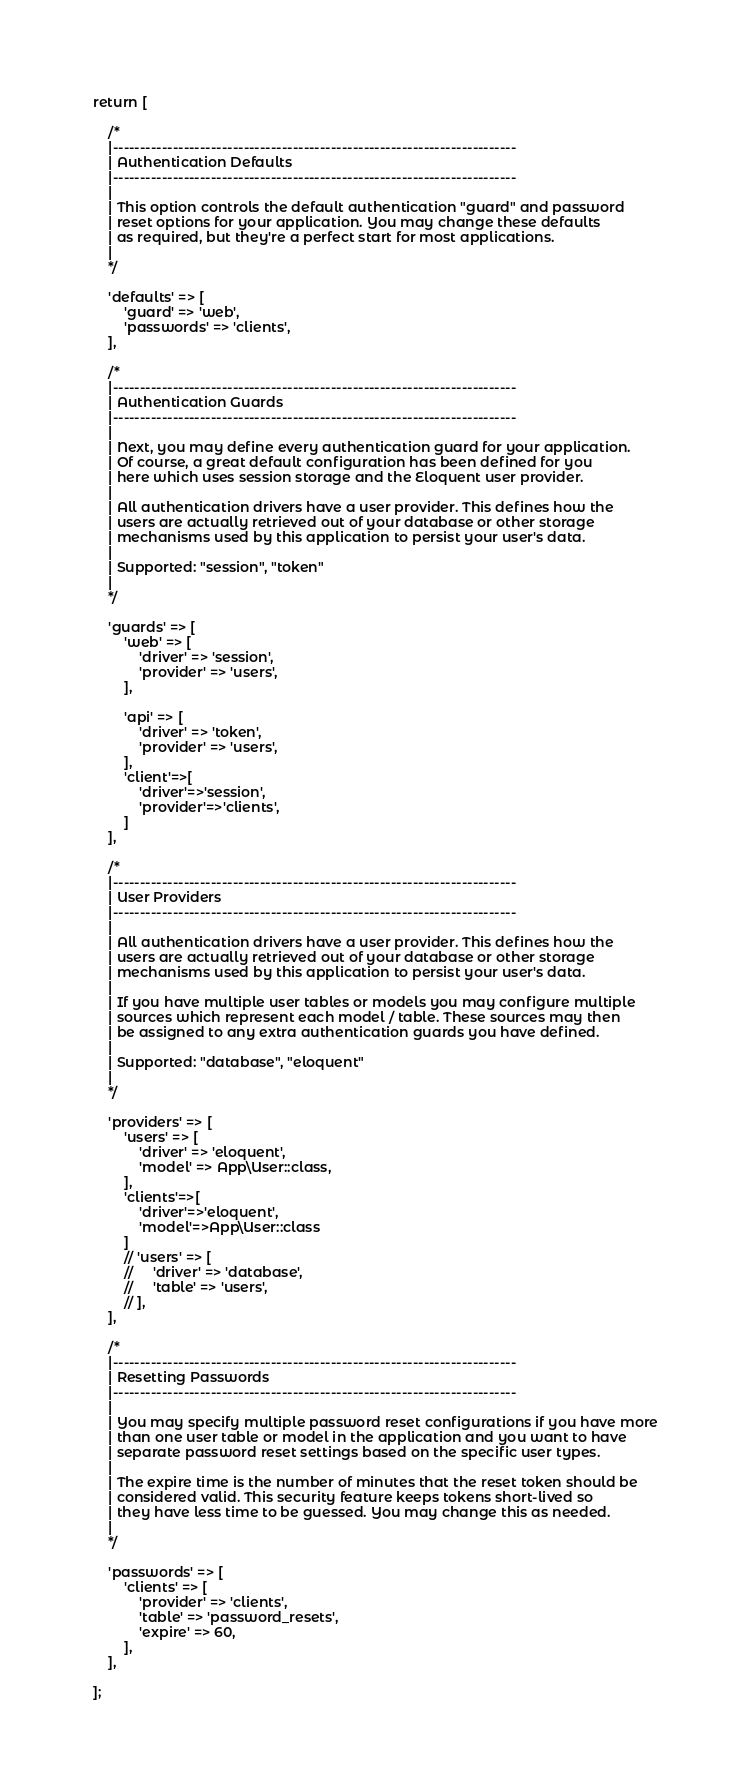<code> <loc_0><loc_0><loc_500><loc_500><_PHP_>
return [

    /*
    |--------------------------------------------------------------------------
    | Authentication Defaults
    |--------------------------------------------------------------------------
    |
    | This option controls the default authentication "guard" and password
    | reset options for your application. You may change these defaults
    | as required, but they're a perfect start for most applications.
    |
    */

    'defaults' => [
        'guard' => 'web',
        'passwords' => 'clients',
    ],

    /*
    |--------------------------------------------------------------------------
    | Authentication Guards
    |--------------------------------------------------------------------------
    |
    | Next, you may define every authentication guard for your application.
    | Of course, a great default configuration has been defined for you
    | here which uses session storage and the Eloquent user provider.
    |
    | All authentication drivers have a user provider. This defines how the
    | users are actually retrieved out of your database or other storage
    | mechanisms used by this application to persist your user's data.
    |
    | Supported: "session", "token"
    |
    */

    'guards' => [
        'web' => [
            'driver' => 'session',
            'provider' => 'users',
        ],

        'api' => [
            'driver' => 'token',
            'provider' => 'users',
        ],
        'client'=>[
            'driver'=>'session',
            'provider'=>'clients',
        ]
    ],

    /*
    |--------------------------------------------------------------------------
    | User Providers
    |--------------------------------------------------------------------------
    |
    | All authentication drivers have a user provider. This defines how the
    | users are actually retrieved out of your database or other storage
    | mechanisms used by this application to persist your user's data.
    |
    | If you have multiple user tables or models you may configure multiple
    | sources which represent each model / table. These sources may then
    | be assigned to any extra authentication guards you have defined.
    |
    | Supported: "database", "eloquent"
    |
    */

    'providers' => [
        'users' => [
            'driver' => 'eloquent',
            'model' => App\User::class,
        ],
        'clients'=>[
            'driver'=>'eloquent',
            'model'=>App\User::class
        ]
        // 'users' => [
        //     'driver' => 'database',
        //     'table' => 'users',
        // ],
    ],

    /*
    |--------------------------------------------------------------------------
    | Resetting Passwords
    |--------------------------------------------------------------------------
    |
    | You may specify multiple password reset configurations if you have more
    | than one user table or model in the application and you want to have
    | separate password reset settings based on the specific user types.
    |
    | The expire time is the number of minutes that the reset token should be
    | considered valid. This security feature keeps tokens short-lived so
    | they have less time to be guessed. You may change this as needed.
    |
    */

    'passwords' => [
        'clients' => [
            'provider' => 'clients',
            'table' => 'password_resets',
            'expire' => 60,
        ],
    ],

];
</code> 